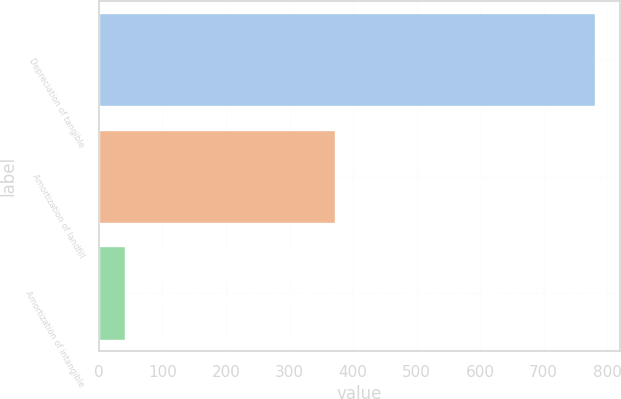Convert chart. <chart><loc_0><loc_0><loc_500><loc_500><bar_chart><fcel>Depreciation of tangible<fcel>Amortization of landfill<fcel>Amortization of intangible<nl><fcel>781<fcel>372<fcel>41<nl></chart> 